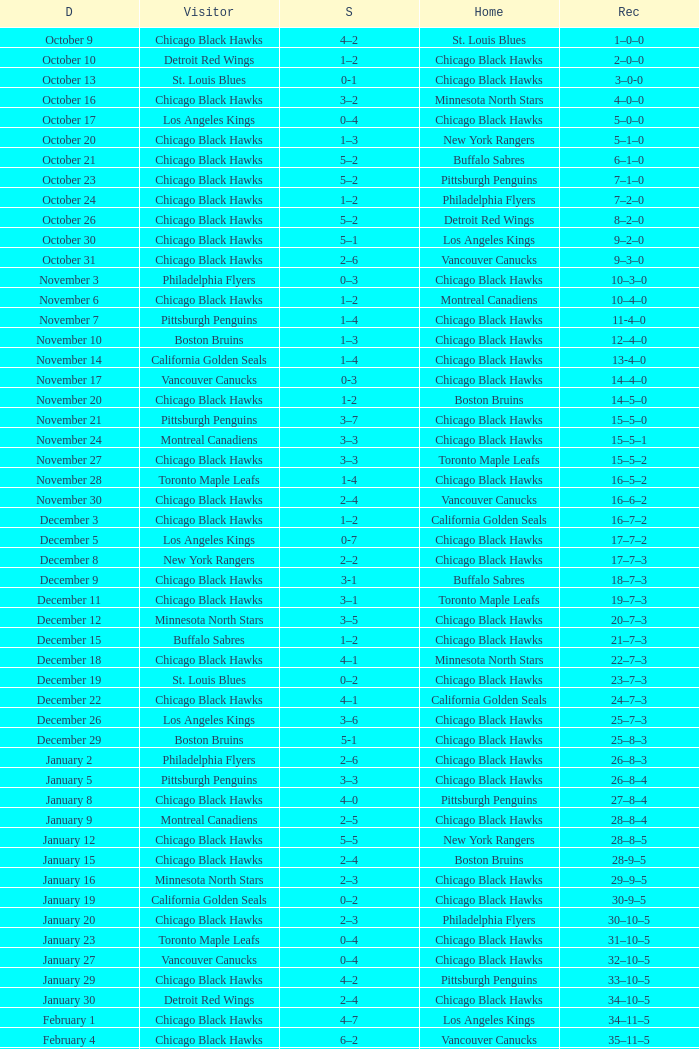What is the Score of the Chicago Black Hawks Home game with the Visiting Vancouver Canucks on November 17? 0-3. 